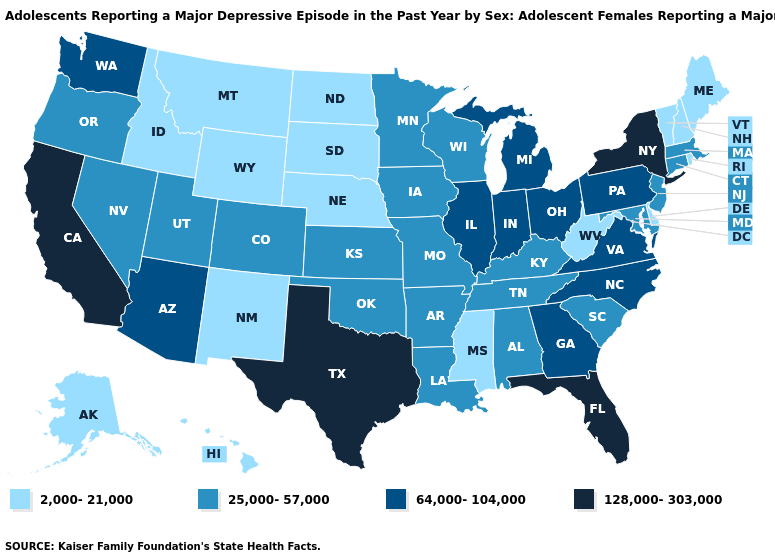What is the value of Mississippi?
Write a very short answer. 2,000-21,000. What is the lowest value in the South?
Be succinct. 2,000-21,000. Does New York have the highest value in the Northeast?
Give a very brief answer. Yes. Does Texas have a lower value than Indiana?
Quick response, please. No. Does Texas have the highest value in the South?
Quick response, please. Yes. Name the states that have a value in the range 128,000-303,000?
Keep it brief. California, Florida, New York, Texas. Among the states that border Nebraska , which have the lowest value?
Short answer required. South Dakota, Wyoming. Name the states that have a value in the range 128,000-303,000?
Answer briefly. California, Florida, New York, Texas. Name the states that have a value in the range 64,000-104,000?
Give a very brief answer. Arizona, Georgia, Illinois, Indiana, Michigan, North Carolina, Ohio, Pennsylvania, Virginia, Washington. What is the value of Oregon?
Quick response, please. 25,000-57,000. Is the legend a continuous bar?
Short answer required. No. Does Georgia have the lowest value in the South?
Write a very short answer. No. Name the states that have a value in the range 2,000-21,000?
Be succinct. Alaska, Delaware, Hawaii, Idaho, Maine, Mississippi, Montana, Nebraska, New Hampshire, New Mexico, North Dakota, Rhode Island, South Dakota, Vermont, West Virginia, Wyoming. What is the value of Arkansas?
Give a very brief answer. 25,000-57,000. Name the states that have a value in the range 2,000-21,000?
Give a very brief answer. Alaska, Delaware, Hawaii, Idaho, Maine, Mississippi, Montana, Nebraska, New Hampshire, New Mexico, North Dakota, Rhode Island, South Dakota, Vermont, West Virginia, Wyoming. 